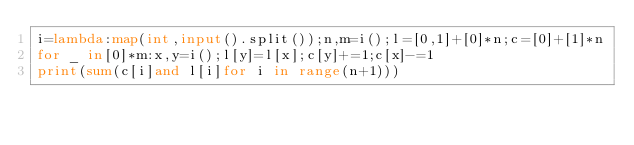Convert code to text. <code><loc_0><loc_0><loc_500><loc_500><_Python_>i=lambda:map(int,input().split());n,m=i();l=[0,1]+[0]*n;c=[0]+[1]*n
for _ in[0]*m:x,y=i();l[y]=l[x];c[y]+=1;c[x]-=1
print(sum(c[i]and l[i]for i in range(n+1)))</code> 